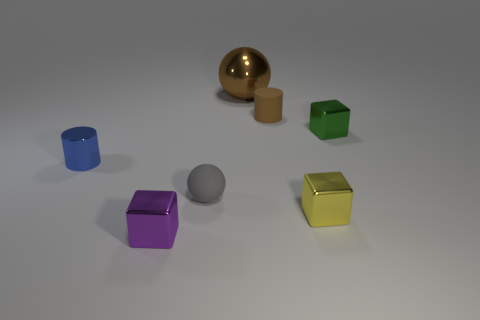Add 1 red matte spheres. How many objects exist? 8 Subtract all cylinders. How many objects are left? 5 Add 7 small brown rubber things. How many small brown rubber things exist? 8 Subtract 0 red balls. How many objects are left? 7 Subtract all large green cylinders. Subtract all small brown cylinders. How many objects are left? 6 Add 6 small matte objects. How many small matte objects are left? 8 